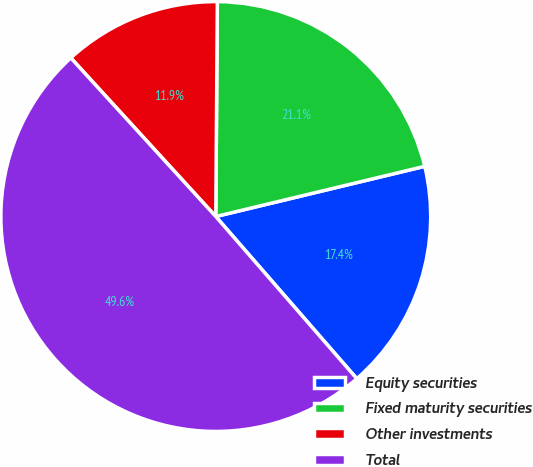<chart> <loc_0><loc_0><loc_500><loc_500><pie_chart><fcel>Equity securities<fcel>Fixed maturity securities<fcel>Other investments<fcel>Total<nl><fcel>17.36%<fcel>21.13%<fcel>11.9%<fcel>49.6%<nl></chart> 